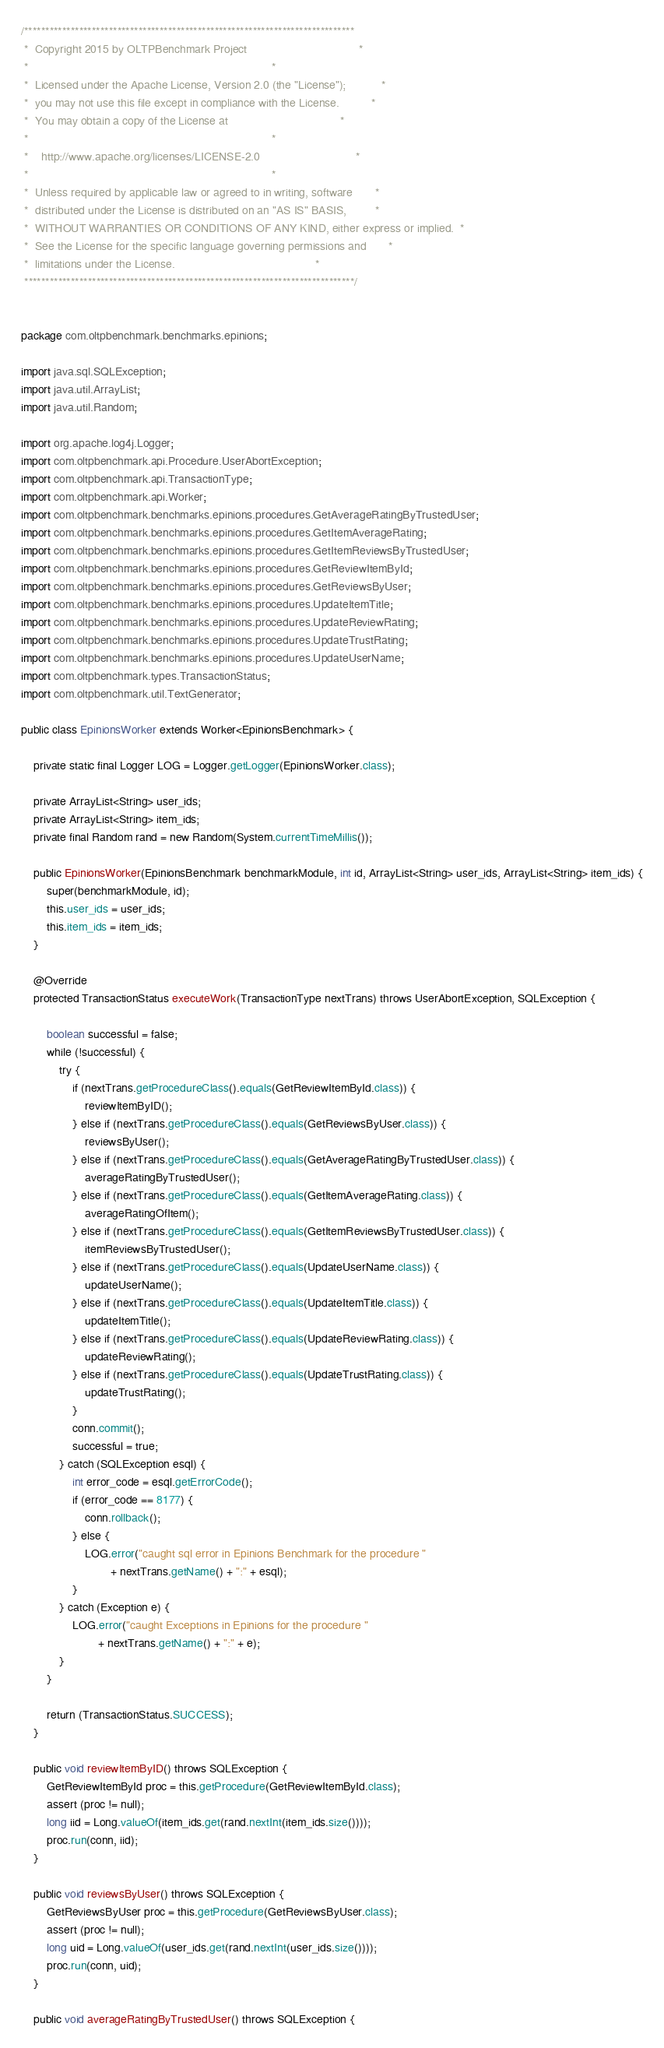Convert code to text. <code><loc_0><loc_0><loc_500><loc_500><_Java_>/******************************************************************************
 *  Copyright 2015 by OLTPBenchmark Project                                   *
 *                                                                            *
 *  Licensed under the Apache License, Version 2.0 (the "License");           *
 *  you may not use this file except in compliance with the License.          *
 *  You may obtain a copy of the License at                                   *
 *                                                                            *
 *    http://www.apache.org/licenses/LICENSE-2.0                              *
 *                                                                            *
 *  Unless required by applicable law or agreed to in writing, software       *
 *  distributed under the License is distributed on an "AS IS" BASIS,         *
 *  WITHOUT WARRANTIES OR CONDITIONS OF ANY KIND, either express or implied.  *
 *  See the License for the specific language governing permissions and       *
 *  limitations under the License.                                            *
 ******************************************************************************/


package com.oltpbenchmark.benchmarks.epinions;

import java.sql.SQLException;
import java.util.ArrayList;
import java.util.Random;

import org.apache.log4j.Logger;
import com.oltpbenchmark.api.Procedure.UserAbortException;
import com.oltpbenchmark.api.TransactionType;
import com.oltpbenchmark.api.Worker;
import com.oltpbenchmark.benchmarks.epinions.procedures.GetAverageRatingByTrustedUser;
import com.oltpbenchmark.benchmarks.epinions.procedures.GetItemAverageRating;
import com.oltpbenchmark.benchmarks.epinions.procedures.GetItemReviewsByTrustedUser;
import com.oltpbenchmark.benchmarks.epinions.procedures.GetReviewItemById;
import com.oltpbenchmark.benchmarks.epinions.procedures.GetReviewsByUser;
import com.oltpbenchmark.benchmarks.epinions.procedures.UpdateItemTitle;
import com.oltpbenchmark.benchmarks.epinions.procedures.UpdateReviewRating;
import com.oltpbenchmark.benchmarks.epinions.procedures.UpdateTrustRating;
import com.oltpbenchmark.benchmarks.epinions.procedures.UpdateUserName;
import com.oltpbenchmark.types.TransactionStatus;
import com.oltpbenchmark.util.TextGenerator;

public class EpinionsWorker extends Worker<EpinionsBenchmark> {
	
	private static final Logger LOG = Logger.getLogger(EpinionsWorker.class);

    private ArrayList<String> user_ids;
    private ArrayList<String> item_ids;
    private final Random rand = new Random(System.currentTimeMillis());

    public EpinionsWorker(EpinionsBenchmark benchmarkModule, int id, ArrayList<String> user_ids, ArrayList<String> item_ids) {
        super(benchmarkModule, id);
        this.user_ids = user_ids;
        this.item_ids = item_ids;
    }

    @Override
    protected TransactionStatus executeWork(TransactionType nextTrans) throws UserAbortException, SQLException {
        
    	boolean successful = false;
		while (!successful) {
			try {
				if (nextTrans.getProcedureClass().equals(GetReviewItemById.class)) {
					reviewItemByID();
				} else if (nextTrans.getProcedureClass().equals(GetReviewsByUser.class)) {
					reviewsByUser();
				} else if (nextTrans.getProcedureClass().equals(GetAverageRatingByTrustedUser.class)) {
					averageRatingByTrustedUser();
				} else if (nextTrans.getProcedureClass().equals(GetItemAverageRating.class)) {
					averageRatingOfItem();
				} else if (nextTrans.getProcedureClass().equals(GetItemReviewsByTrustedUser.class)) {
					itemReviewsByTrustedUser();
				} else if (nextTrans.getProcedureClass().equals(UpdateUserName.class)) {
					updateUserName();
				} else if (nextTrans.getProcedureClass().equals(UpdateItemTitle.class)) {
					updateItemTitle();
				} else if (nextTrans.getProcedureClass().equals(UpdateReviewRating.class)) {
					updateReviewRating();
				} else if (nextTrans.getProcedureClass().equals(UpdateTrustRating.class)) {
					updateTrustRating();
				}
				conn.commit();
				successful = true;
			} catch (SQLException esql) {
				int error_code = esql.getErrorCode();
				if (error_code == 8177) {
					conn.rollback();
				} else {
					LOG.error("caught sql error in Epinions Benchmark for the procedure "
							+ nextTrans.getName() + ":" + esql);
				}
			} catch (Exception e) {
				LOG.error("caught Exceptions in Epinions for the procedure "
						+ nextTrans.getName() + ":" + e);
			}
		}

        return (TransactionStatus.SUCCESS);
    }

    public void reviewItemByID() throws SQLException {
        GetReviewItemById proc = this.getProcedure(GetReviewItemById.class);
        assert (proc != null);
        long iid = Long.valueOf(item_ids.get(rand.nextInt(item_ids.size())));
        proc.run(conn, iid);
    }

    public void reviewsByUser() throws SQLException {
        GetReviewsByUser proc = this.getProcedure(GetReviewsByUser.class);
        assert (proc != null);
        long uid = Long.valueOf(user_ids.get(rand.nextInt(user_ids.size())));
        proc.run(conn, uid);
    }

    public void averageRatingByTrustedUser() throws SQLException {</code> 